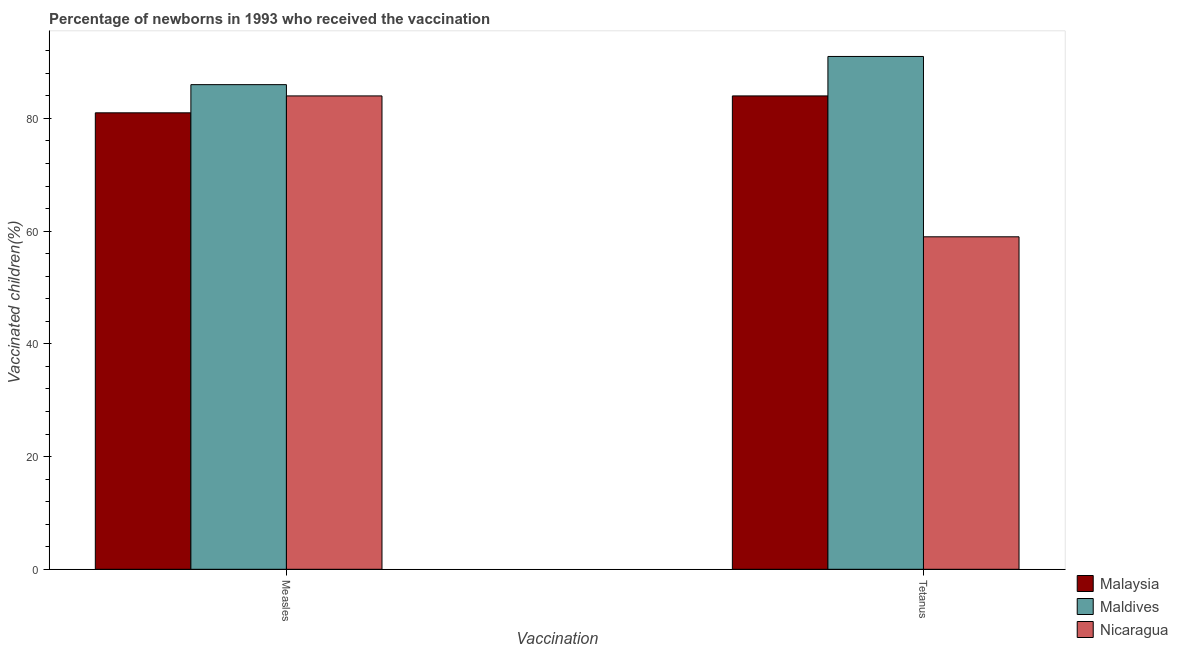How many different coloured bars are there?
Offer a very short reply. 3. How many groups of bars are there?
Provide a short and direct response. 2. Are the number of bars on each tick of the X-axis equal?
Provide a succinct answer. Yes. How many bars are there on the 2nd tick from the right?
Provide a short and direct response. 3. What is the label of the 1st group of bars from the left?
Provide a succinct answer. Measles. What is the percentage of newborns who received vaccination for measles in Malaysia?
Your answer should be compact. 81. Across all countries, what is the maximum percentage of newborns who received vaccination for measles?
Give a very brief answer. 86. Across all countries, what is the minimum percentage of newborns who received vaccination for tetanus?
Offer a very short reply. 59. In which country was the percentage of newborns who received vaccination for measles maximum?
Offer a terse response. Maldives. In which country was the percentage of newborns who received vaccination for tetanus minimum?
Ensure brevity in your answer.  Nicaragua. What is the total percentage of newborns who received vaccination for measles in the graph?
Offer a very short reply. 251. What is the difference between the percentage of newborns who received vaccination for measles in Maldives and that in Nicaragua?
Your answer should be compact. 2. What is the difference between the percentage of newborns who received vaccination for tetanus in Maldives and the percentage of newborns who received vaccination for measles in Nicaragua?
Your answer should be very brief. 7. What is the average percentage of newborns who received vaccination for measles per country?
Provide a succinct answer. 83.67. What is the difference between the percentage of newborns who received vaccination for tetanus and percentage of newborns who received vaccination for measles in Malaysia?
Keep it short and to the point. 3. In how many countries, is the percentage of newborns who received vaccination for tetanus greater than 4 %?
Offer a terse response. 3. What is the ratio of the percentage of newborns who received vaccination for tetanus in Maldives to that in Nicaragua?
Keep it short and to the point. 1.54. Is the percentage of newborns who received vaccination for tetanus in Malaysia less than that in Nicaragua?
Make the answer very short. No. What does the 1st bar from the left in Tetanus represents?
Make the answer very short. Malaysia. What does the 2nd bar from the right in Measles represents?
Your answer should be compact. Maldives. How many bars are there?
Your response must be concise. 6. Are all the bars in the graph horizontal?
Provide a short and direct response. No. How many countries are there in the graph?
Offer a very short reply. 3. Does the graph contain grids?
Ensure brevity in your answer.  No. Where does the legend appear in the graph?
Keep it short and to the point. Bottom right. How many legend labels are there?
Provide a short and direct response. 3. What is the title of the graph?
Offer a very short reply. Percentage of newborns in 1993 who received the vaccination. What is the label or title of the X-axis?
Offer a very short reply. Vaccination. What is the label or title of the Y-axis?
Your response must be concise. Vaccinated children(%)
. What is the Vaccinated children(%)
 of Malaysia in Measles?
Your answer should be compact. 81. What is the Vaccinated children(%)
 of Nicaragua in Measles?
Your answer should be compact. 84. What is the Vaccinated children(%)
 of Malaysia in Tetanus?
Provide a short and direct response. 84. What is the Vaccinated children(%)
 in Maldives in Tetanus?
Your response must be concise. 91. Across all Vaccination, what is the maximum Vaccinated children(%)
 in Maldives?
Offer a very short reply. 91. Across all Vaccination, what is the maximum Vaccinated children(%)
 of Nicaragua?
Make the answer very short. 84. Across all Vaccination, what is the minimum Vaccinated children(%)
 in Nicaragua?
Offer a terse response. 59. What is the total Vaccinated children(%)
 of Malaysia in the graph?
Offer a terse response. 165. What is the total Vaccinated children(%)
 in Maldives in the graph?
Make the answer very short. 177. What is the total Vaccinated children(%)
 of Nicaragua in the graph?
Offer a terse response. 143. What is the difference between the Vaccinated children(%)
 of Malaysia in Measles and that in Tetanus?
Give a very brief answer. -3. What is the difference between the Vaccinated children(%)
 of Malaysia in Measles and the Vaccinated children(%)
 of Maldives in Tetanus?
Give a very brief answer. -10. What is the average Vaccinated children(%)
 of Malaysia per Vaccination?
Offer a very short reply. 82.5. What is the average Vaccinated children(%)
 in Maldives per Vaccination?
Offer a very short reply. 88.5. What is the average Vaccinated children(%)
 of Nicaragua per Vaccination?
Your response must be concise. 71.5. What is the difference between the Vaccinated children(%)
 in Malaysia and Vaccinated children(%)
 in Maldives in Measles?
Keep it short and to the point. -5. What is the difference between the Vaccinated children(%)
 of Malaysia and Vaccinated children(%)
 of Nicaragua in Measles?
Your answer should be very brief. -3. What is the difference between the Vaccinated children(%)
 in Maldives and Vaccinated children(%)
 in Nicaragua in Measles?
Your response must be concise. 2. What is the difference between the Vaccinated children(%)
 of Malaysia and Vaccinated children(%)
 of Nicaragua in Tetanus?
Make the answer very short. 25. What is the ratio of the Vaccinated children(%)
 in Malaysia in Measles to that in Tetanus?
Ensure brevity in your answer.  0.96. What is the ratio of the Vaccinated children(%)
 of Maldives in Measles to that in Tetanus?
Provide a succinct answer. 0.95. What is the ratio of the Vaccinated children(%)
 of Nicaragua in Measles to that in Tetanus?
Offer a very short reply. 1.42. What is the difference between the highest and the second highest Vaccinated children(%)
 in Malaysia?
Your response must be concise. 3. What is the difference between the highest and the second highest Vaccinated children(%)
 in Maldives?
Provide a succinct answer. 5. What is the difference between the highest and the lowest Vaccinated children(%)
 of Nicaragua?
Offer a very short reply. 25. 